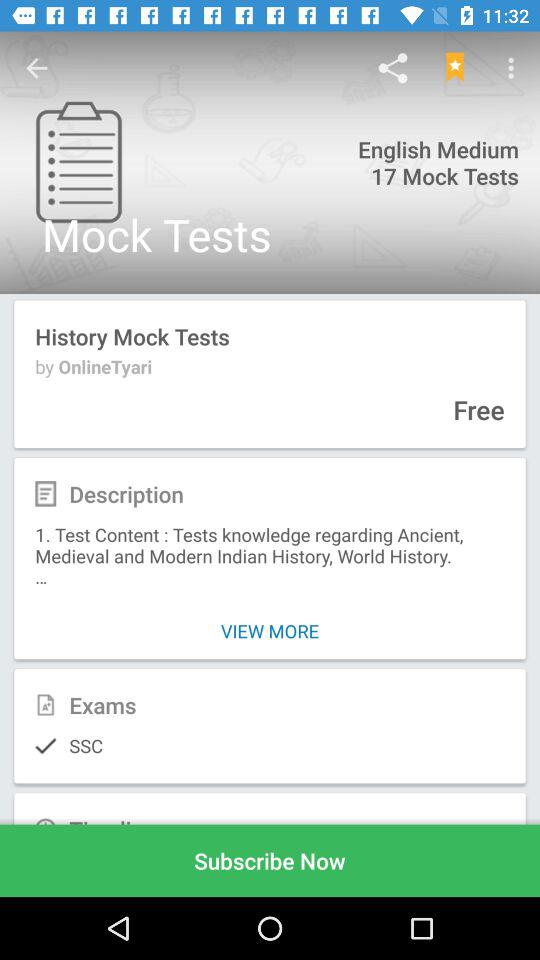How many bookmarks do I have for this article?
Answer the question using a single word or phrase. 94 